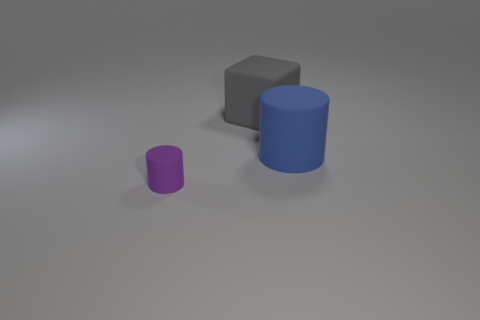Add 1 big blue objects. How many objects exist? 4 Subtract all cubes. How many objects are left? 2 Subtract 0 cyan balls. How many objects are left? 3 Subtract all gray matte things. Subtract all big gray rubber things. How many objects are left? 1 Add 1 purple rubber things. How many purple rubber things are left? 2 Add 2 small yellow metallic cylinders. How many small yellow metallic cylinders exist? 2 